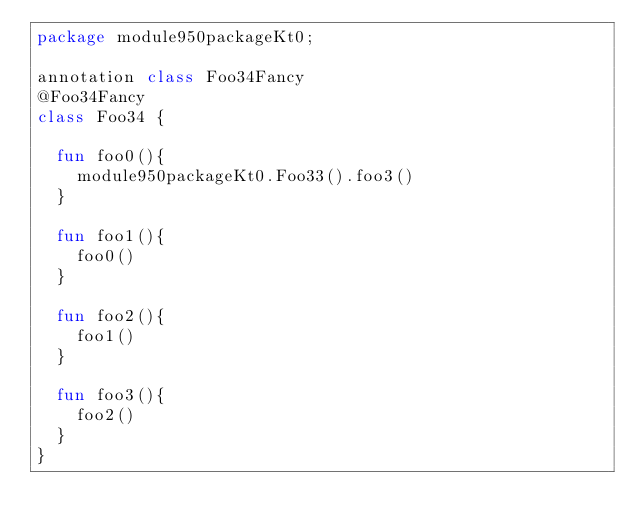<code> <loc_0><loc_0><loc_500><loc_500><_Kotlin_>package module950packageKt0;

annotation class Foo34Fancy
@Foo34Fancy
class Foo34 {

  fun foo0(){
    module950packageKt0.Foo33().foo3()
  }

  fun foo1(){
    foo0()
  }

  fun foo2(){
    foo1()
  }

  fun foo3(){
    foo2()
  }
}</code> 